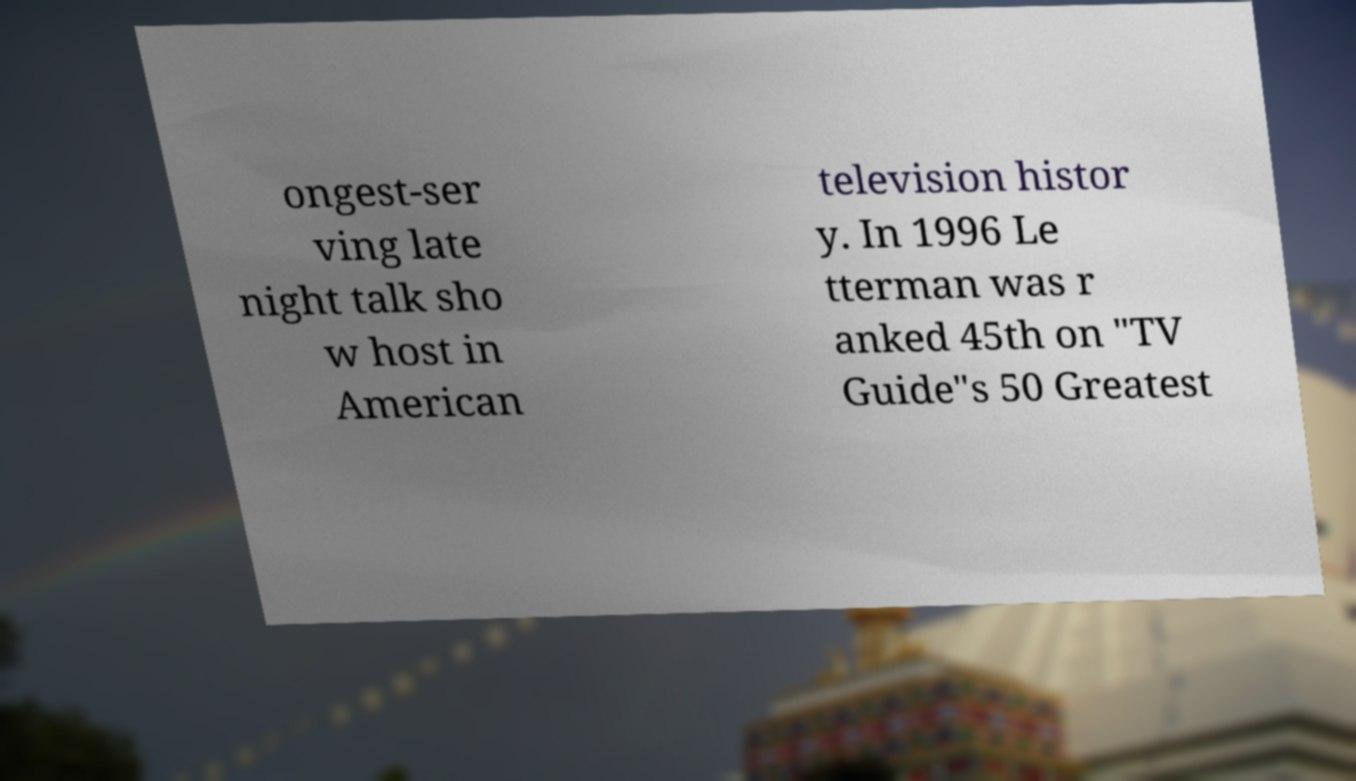I need the written content from this picture converted into text. Can you do that? ongest-ser ving late night talk sho w host in American television histor y. In 1996 Le tterman was r anked 45th on "TV Guide"s 50 Greatest 